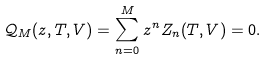<formula> <loc_0><loc_0><loc_500><loc_500>\mathcal { Q } _ { M } ( z , T , V ) = \sum _ { n = 0 } ^ { M } z ^ { n } Z _ { n } ( T , V ) = 0 .</formula> 